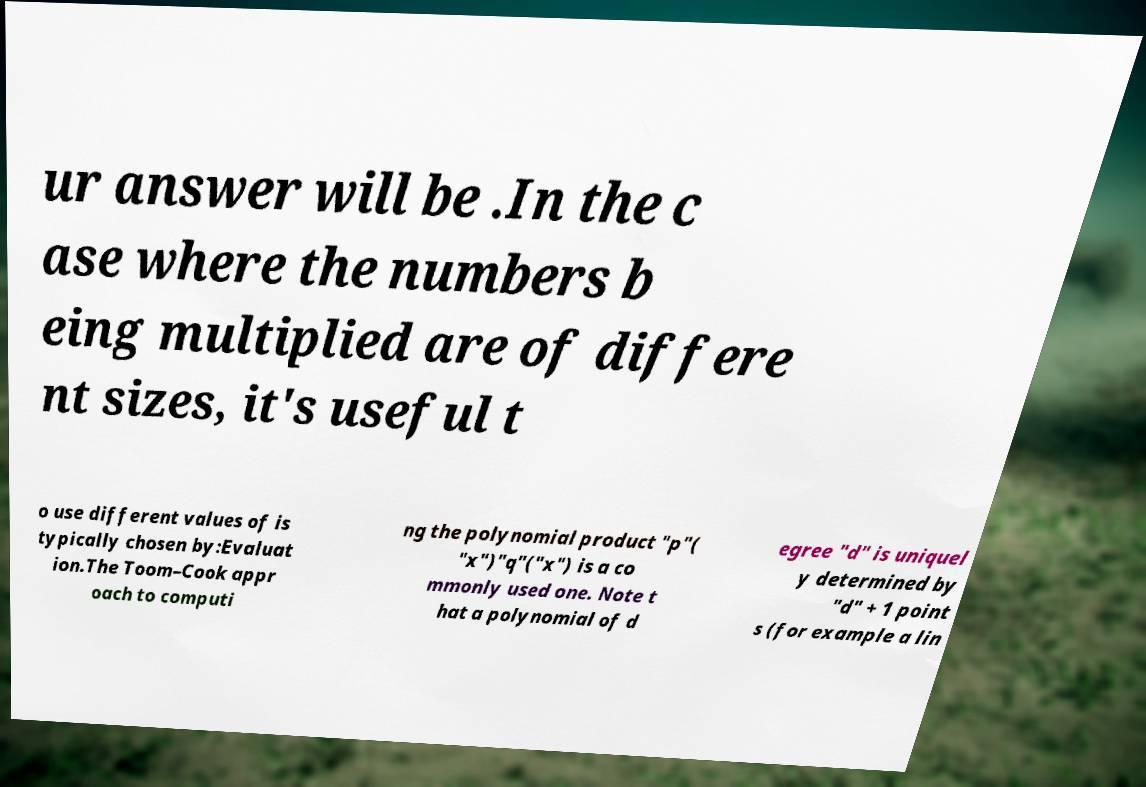Can you read and provide the text displayed in the image?This photo seems to have some interesting text. Can you extract and type it out for me? ur answer will be .In the c ase where the numbers b eing multiplied are of differe nt sizes, it's useful t o use different values of is typically chosen by:Evaluat ion.The Toom–Cook appr oach to computi ng the polynomial product "p"( "x")"q"("x") is a co mmonly used one. Note t hat a polynomial of d egree "d" is uniquel y determined by "d" + 1 point s (for example a lin 